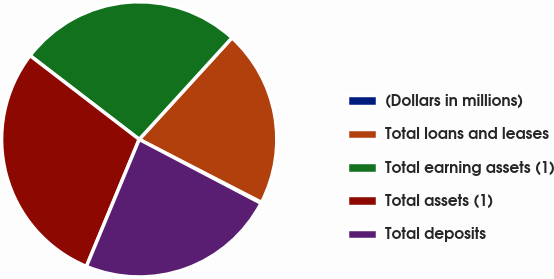<chart> <loc_0><loc_0><loc_500><loc_500><pie_chart><fcel>(Dollars in millions)<fcel>Total loans and leases<fcel>Total earning assets (1)<fcel>Total assets (1)<fcel>Total deposits<nl><fcel>0.12%<fcel>20.79%<fcel>26.36%<fcel>29.15%<fcel>23.58%<nl></chart> 